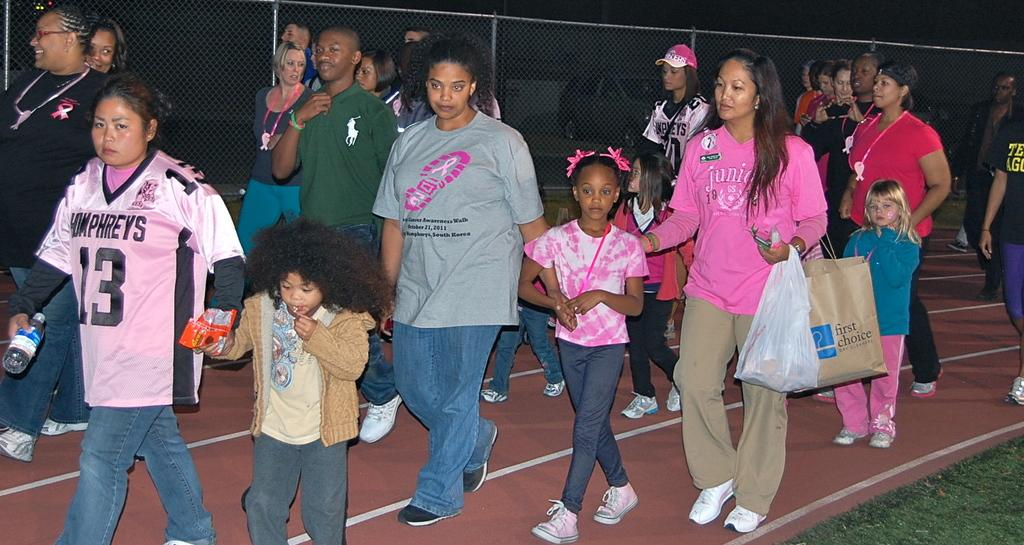<image>
Create a compact narrative representing the image presented. a lady in a pink tshirt is carrying around a brown bag with the words first choice wrote on it 